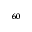Convert formula to latex. <formula><loc_0><loc_0><loc_500><loc_500>_ { 6 0 }</formula> 